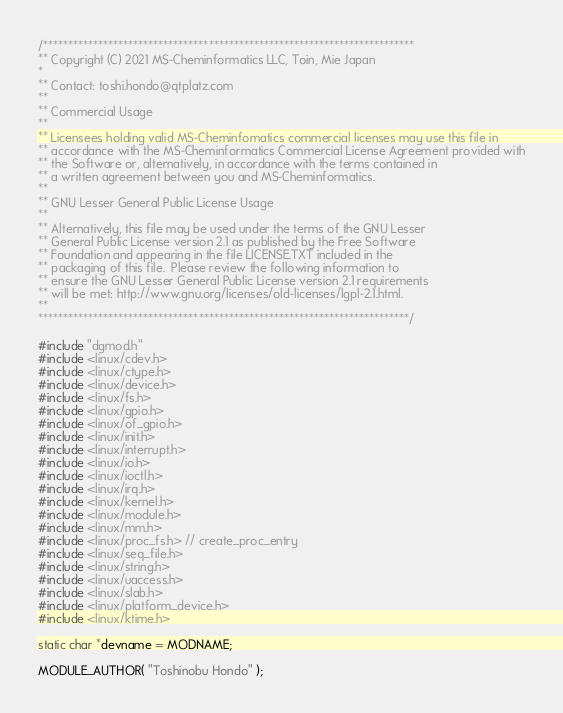Convert code to text. <code><loc_0><loc_0><loc_500><loc_500><_C_>/**************************************************************************
** Copyright (C) 2021 MS-Cheminformatics LLC, Toin, Mie Japan
*
** Contact: toshi.hondo@qtplatz.com
**
** Commercial Usage
**
** Licensees holding valid MS-Cheminfomatics commercial licenses may use this file in
** accordance with the MS-Cheminformatics Commercial License Agreement provided with
** the Software or, alternatively, in accordance with the terms contained in
** a written agreement between you and MS-Cheminformatics.
**
** GNU Lesser General Public License Usage
**
** Alternatively, this file may be used under the terms of the GNU Lesser
** General Public License version 2.1 as published by the Free Software
** Foundation and appearing in the file LICENSE.TXT included in the
** packaging of this file.  Please review the following information to
** ensure the GNU Lesser General Public License version 2.1 requirements
** will be met: http://www.gnu.org/licenses/old-licenses/lgpl-2.1.html.
**
**************************************************************************/

#include "dgmod.h"
#include <linux/cdev.h>
#include <linux/ctype.h>
#include <linux/device.h>
#include <linux/fs.h>
#include <linux/gpio.h>
#include <linux/of_gpio.h>
#include <linux/init.h>
#include <linux/interrupt.h>
#include <linux/io.h>
#include <linux/ioctl.h>
#include <linux/irq.h>
#include <linux/kernel.h>
#include <linux/module.h>
#include <linux/mm.h>
#include <linux/proc_fs.h> // create_proc_entry
#include <linux/seq_file.h>
#include <linux/string.h>
#include <linux/uaccess.h>
#include <linux/slab.h>
#include <linux/platform_device.h>
#include <linux/ktime.h>

static char *devname = MODNAME;

MODULE_AUTHOR( "Toshinobu Hondo" );</code> 